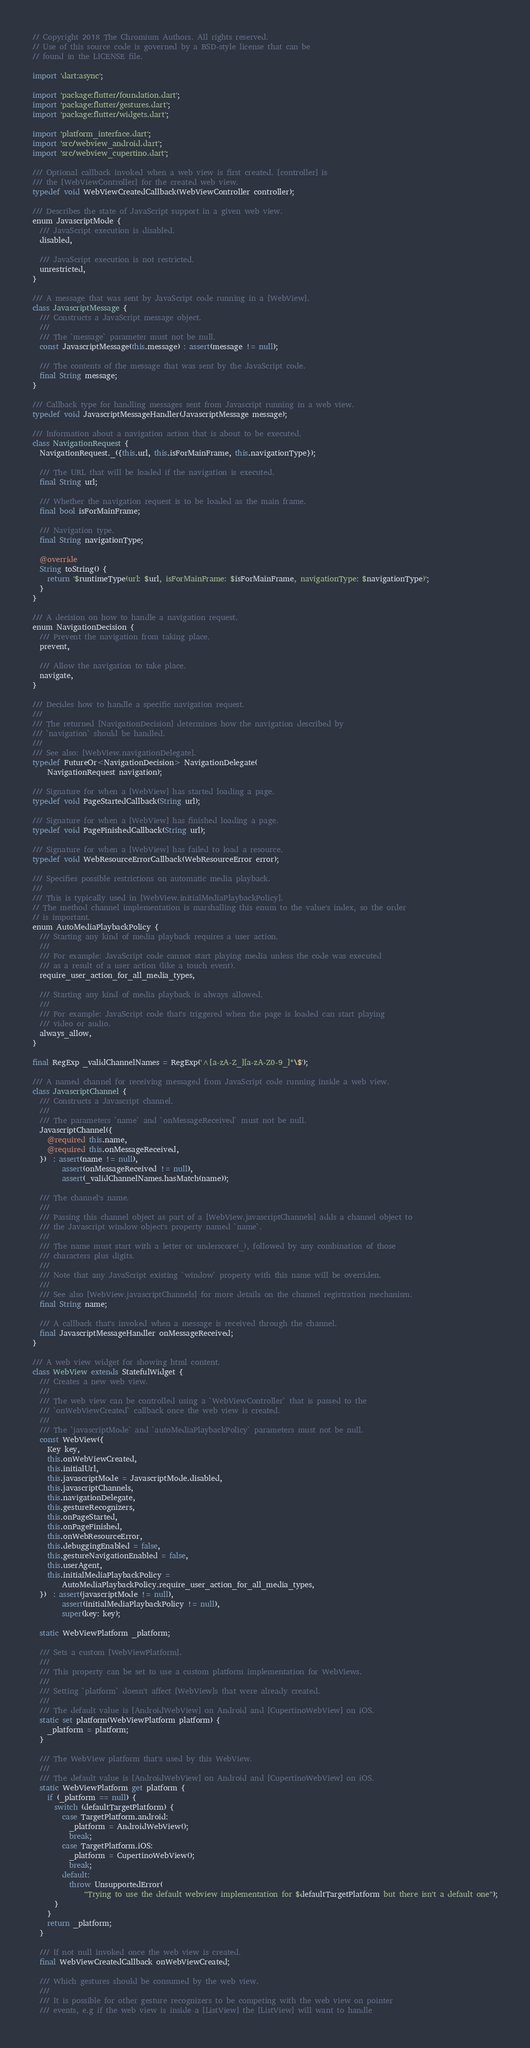Convert code to text. <code><loc_0><loc_0><loc_500><loc_500><_Dart_>// Copyright 2018 The Chromium Authors. All rights reserved.
// Use of this source code is governed by a BSD-style license that can be
// found in the LICENSE file.

import 'dart:async';

import 'package:flutter/foundation.dart';
import 'package:flutter/gestures.dart';
import 'package:flutter/widgets.dart';

import 'platform_interface.dart';
import 'src/webview_android.dart';
import 'src/webview_cupertino.dart';

/// Optional callback invoked when a web view is first created. [controller] is
/// the [WebViewController] for the created web view.
typedef void WebViewCreatedCallback(WebViewController controller);

/// Describes the state of JavaScript support in a given web view.
enum JavascriptMode {
  /// JavaScript execution is disabled.
  disabled,

  /// JavaScript execution is not restricted.
  unrestricted,
}

/// A message that was sent by JavaScript code running in a [WebView].
class JavascriptMessage {
  /// Constructs a JavaScript message object.
  ///
  /// The `message` parameter must not be null.
  const JavascriptMessage(this.message) : assert(message != null);

  /// The contents of the message that was sent by the JavaScript code.
  final String message;
}

/// Callback type for handling messages sent from Javascript running in a web view.
typedef void JavascriptMessageHandler(JavascriptMessage message);

/// Information about a navigation action that is about to be executed.
class NavigationRequest {
  NavigationRequest._({this.url, this.isForMainFrame, this.navigationType});

  /// The URL that will be loaded if the navigation is executed.
  final String url;

  /// Whether the navigation request is to be loaded as the main frame.
  final bool isForMainFrame;

  /// Navigation type.
  final String navigationType;

  @override
  String toString() {
    return '$runtimeType(url: $url, isForMainFrame: $isForMainFrame, navigationType: $navigationType)';
  }
}

/// A decision on how to handle a navigation request.
enum NavigationDecision {
  /// Prevent the navigation from taking place.
  prevent,

  /// Allow the navigation to take place.
  navigate,
}

/// Decides how to handle a specific navigation request.
///
/// The returned [NavigationDecision] determines how the navigation described by
/// `navigation` should be handled.
///
/// See also: [WebView.navigationDelegate].
typedef FutureOr<NavigationDecision> NavigationDelegate(
    NavigationRequest navigation);

/// Signature for when a [WebView] has started loading a page.
typedef void PageStartedCallback(String url);

/// Signature for when a [WebView] has finished loading a page.
typedef void PageFinishedCallback(String url);

/// Signature for when a [WebView] has failed to load a resource.
typedef void WebResourceErrorCallback(WebResourceError error);

/// Specifies possible restrictions on automatic media playback.
///
/// This is typically used in [WebView.initialMediaPlaybackPolicy].
// The method channel implementation is marshalling this enum to the value's index, so the order
// is important.
enum AutoMediaPlaybackPolicy {
  /// Starting any kind of media playback requires a user action.
  ///
  /// For example: JavaScript code cannot start playing media unless the code was executed
  /// as a result of a user action (like a touch event).
  require_user_action_for_all_media_types,

  /// Starting any kind of media playback is always allowed.
  ///
  /// For example: JavaScript code that's triggered when the page is loaded can start playing
  /// video or audio.
  always_allow,
}

final RegExp _validChannelNames = RegExp('^[a-zA-Z_][a-zA-Z0-9_]*\$');

/// A named channel for receiving messaged from JavaScript code running inside a web view.
class JavascriptChannel {
  /// Constructs a Javascript channel.
  ///
  /// The parameters `name` and `onMessageReceived` must not be null.
  JavascriptChannel({
    @required this.name,
    @required this.onMessageReceived,
  })  : assert(name != null),
        assert(onMessageReceived != null),
        assert(_validChannelNames.hasMatch(name));

  /// The channel's name.
  ///
  /// Passing this channel object as part of a [WebView.javascriptChannels] adds a channel object to
  /// the Javascript window object's property named `name`.
  ///
  /// The name must start with a letter or underscore(_), followed by any combination of those
  /// characters plus digits.
  ///
  /// Note that any JavaScript existing `window` property with this name will be overriden.
  ///
  /// See also [WebView.javascriptChannels] for more details on the channel registration mechanism.
  final String name;

  /// A callback that's invoked when a message is received through the channel.
  final JavascriptMessageHandler onMessageReceived;
}

/// A web view widget for showing html content.
class WebView extends StatefulWidget {
  /// Creates a new web view.
  ///
  /// The web view can be controlled using a `WebViewController` that is passed to the
  /// `onWebViewCreated` callback once the web view is created.
  ///
  /// The `javascriptMode` and `autoMediaPlaybackPolicy` parameters must not be null.
  const WebView({
    Key key,
    this.onWebViewCreated,
    this.initialUrl,
    this.javascriptMode = JavascriptMode.disabled,
    this.javascriptChannels,
    this.navigationDelegate,
    this.gestureRecognizers,
    this.onPageStarted,
    this.onPageFinished,
    this.onWebResourceError,
    this.debuggingEnabled = false,
    this.gestureNavigationEnabled = false,
    this.userAgent,
    this.initialMediaPlaybackPolicy =
        AutoMediaPlaybackPolicy.require_user_action_for_all_media_types,
  })  : assert(javascriptMode != null),
        assert(initialMediaPlaybackPolicy != null),
        super(key: key);

  static WebViewPlatform _platform;

  /// Sets a custom [WebViewPlatform].
  ///
  /// This property can be set to use a custom platform implementation for WebViews.
  ///
  /// Setting `platform` doesn't affect [WebView]s that were already created.
  ///
  /// The default value is [AndroidWebView] on Android and [CupertinoWebView] on iOS.
  static set platform(WebViewPlatform platform) {
    _platform = platform;
  }

  /// The WebView platform that's used by this WebView.
  ///
  /// The default value is [AndroidWebView] on Android and [CupertinoWebView] on iOS.
  static WebViewPlatform get platform {
    if (_platform == null) {
      switch (defaultTargetPlatform) {
        case TargetPlatform.android:
          _platform = AndroidWebView();
          break;
        case TargetPlatform.iOS:
          _platform = CupertinoWebView();
          break;
        default:
          throw UnsupportedError(
              "Trying to use the default webview implementation for $defaultTargetPlatform but there isn't a default one");
      }
    }
    return _platform;
  }

  /// If not null invoked once the web view is created.
  final WebViewCreatedCallback onWebViewCreated;

  /// Which gestures should be consumed by the web view.
  ///
  /// It is possible for other gesture recognizers to be competing with the web view on pointer
  /// events, e.g if the web view is inside a [ListView] the [ListView] will want to handle</code> 